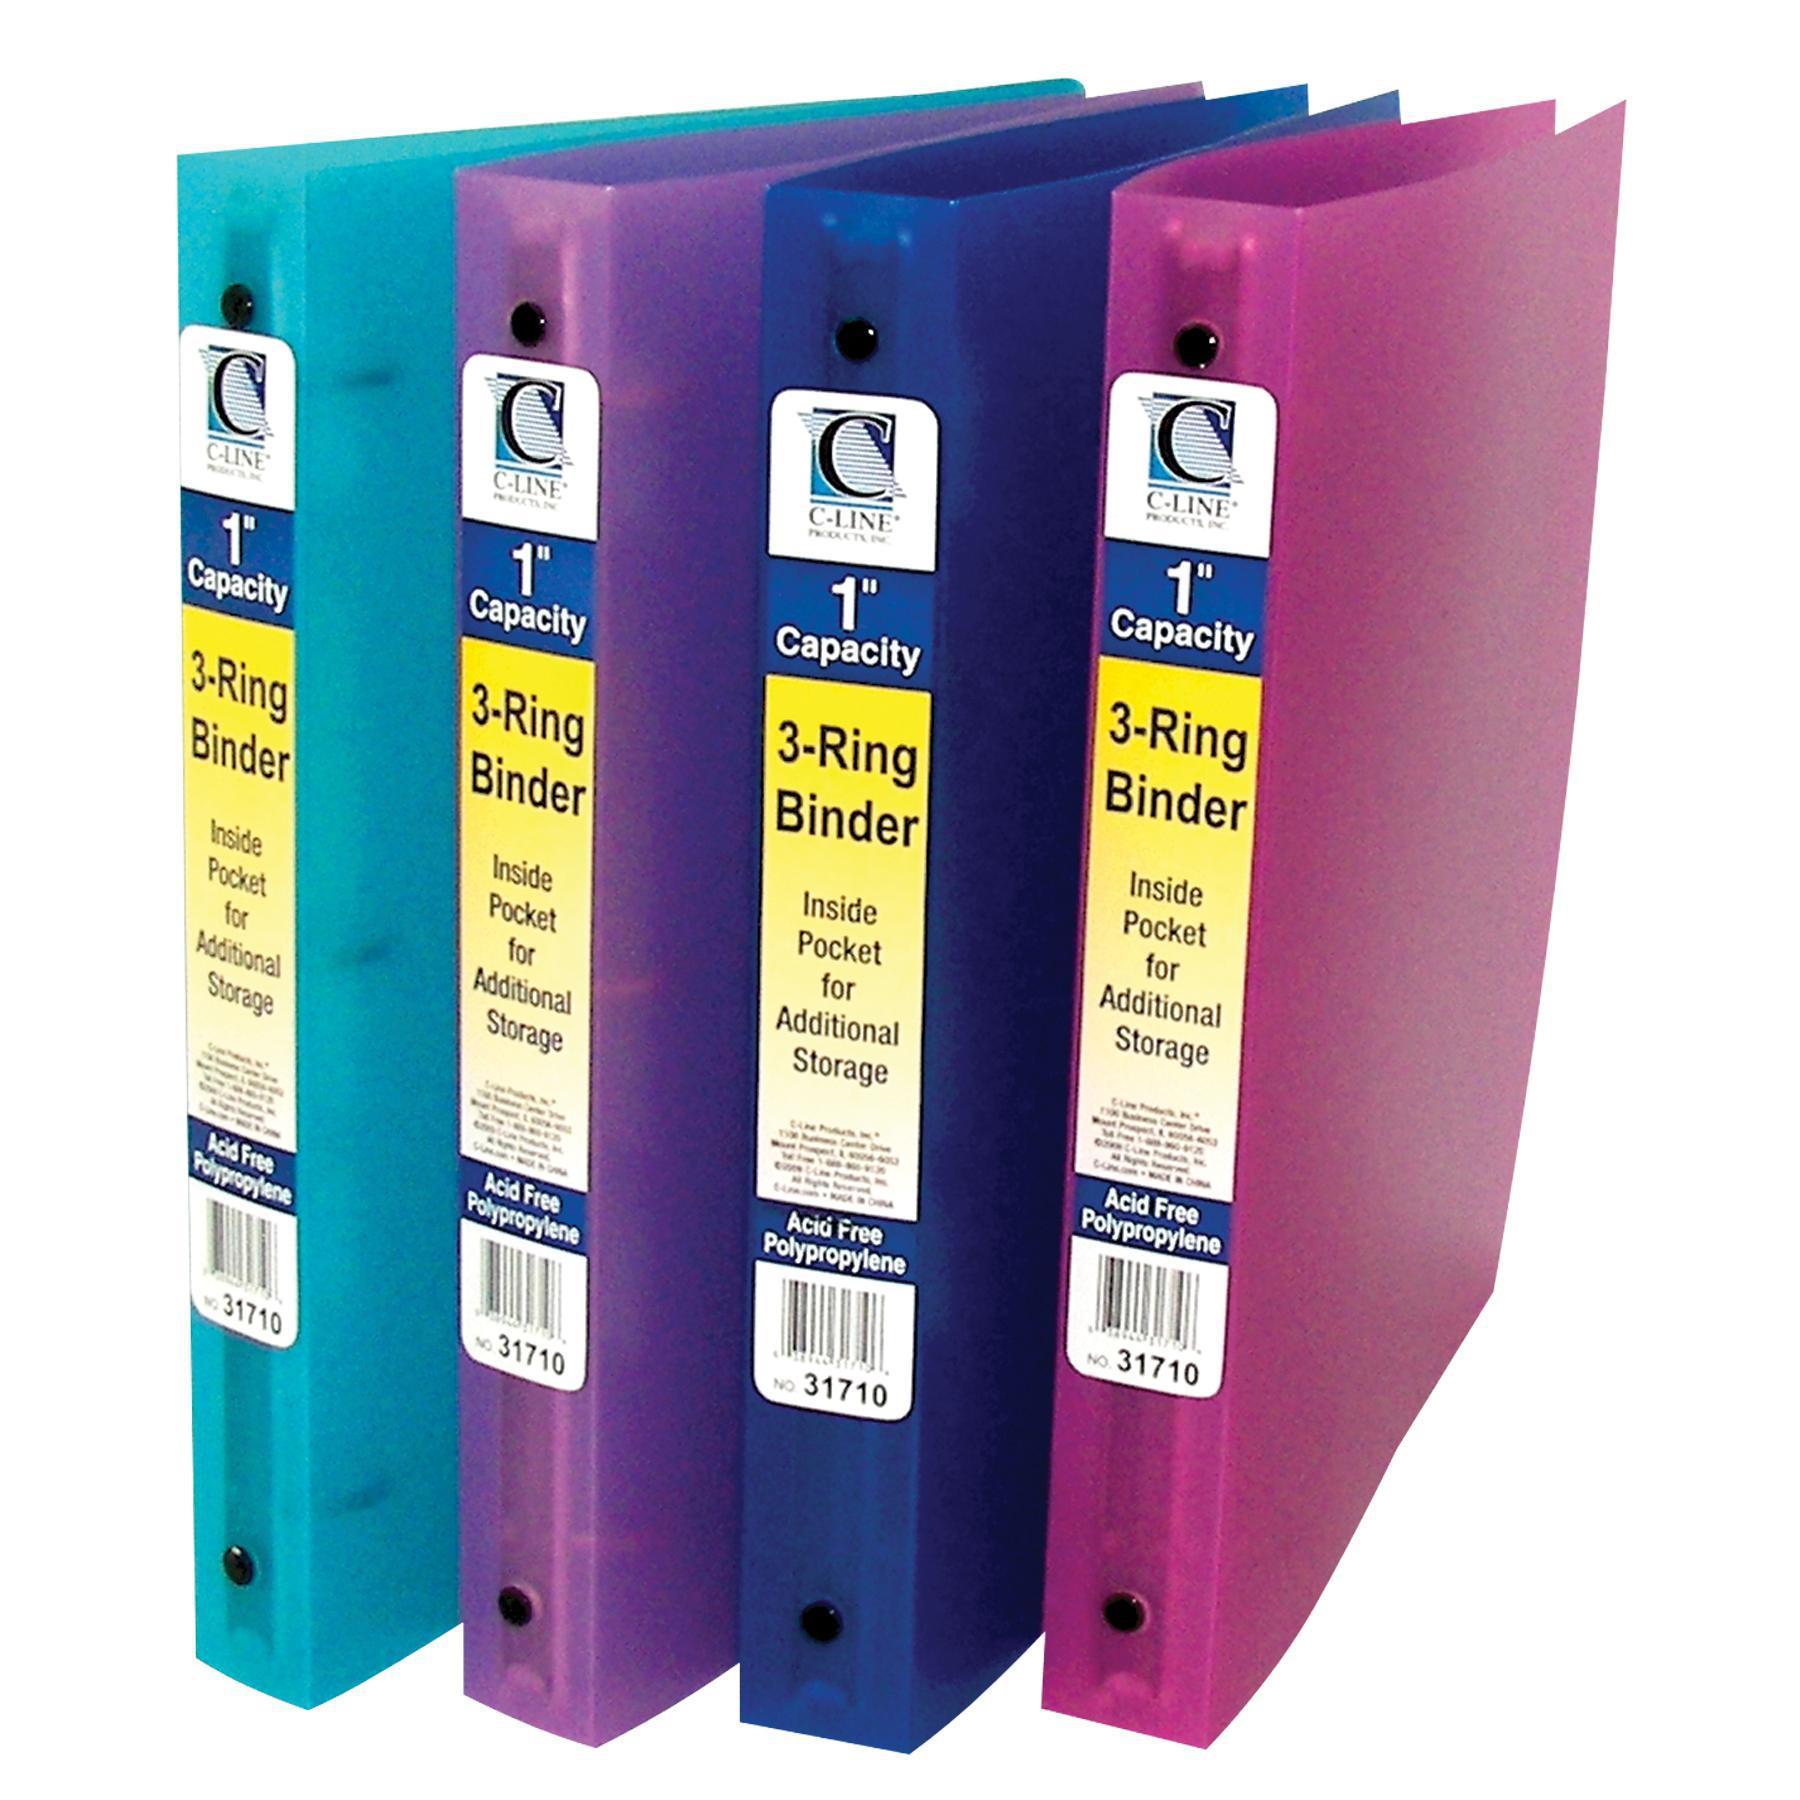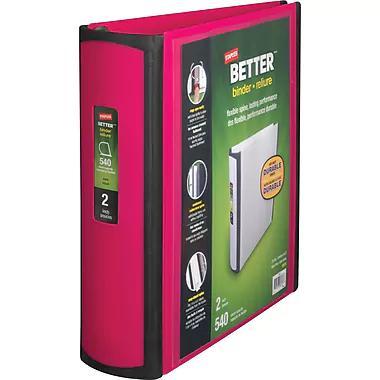The first image is the image on the left, the second image is the image on the right. Given the left and right images, does the statement "One image contains a single upright binder, and the other contains a row of four binders." hold true? Answer yes or no. Yes. The first image is the image on the left, the second image is the image on the right. Assess this claim about the two images: "There are five binders in the image pair.". Correct or not? Answer yes or no. Yes. 